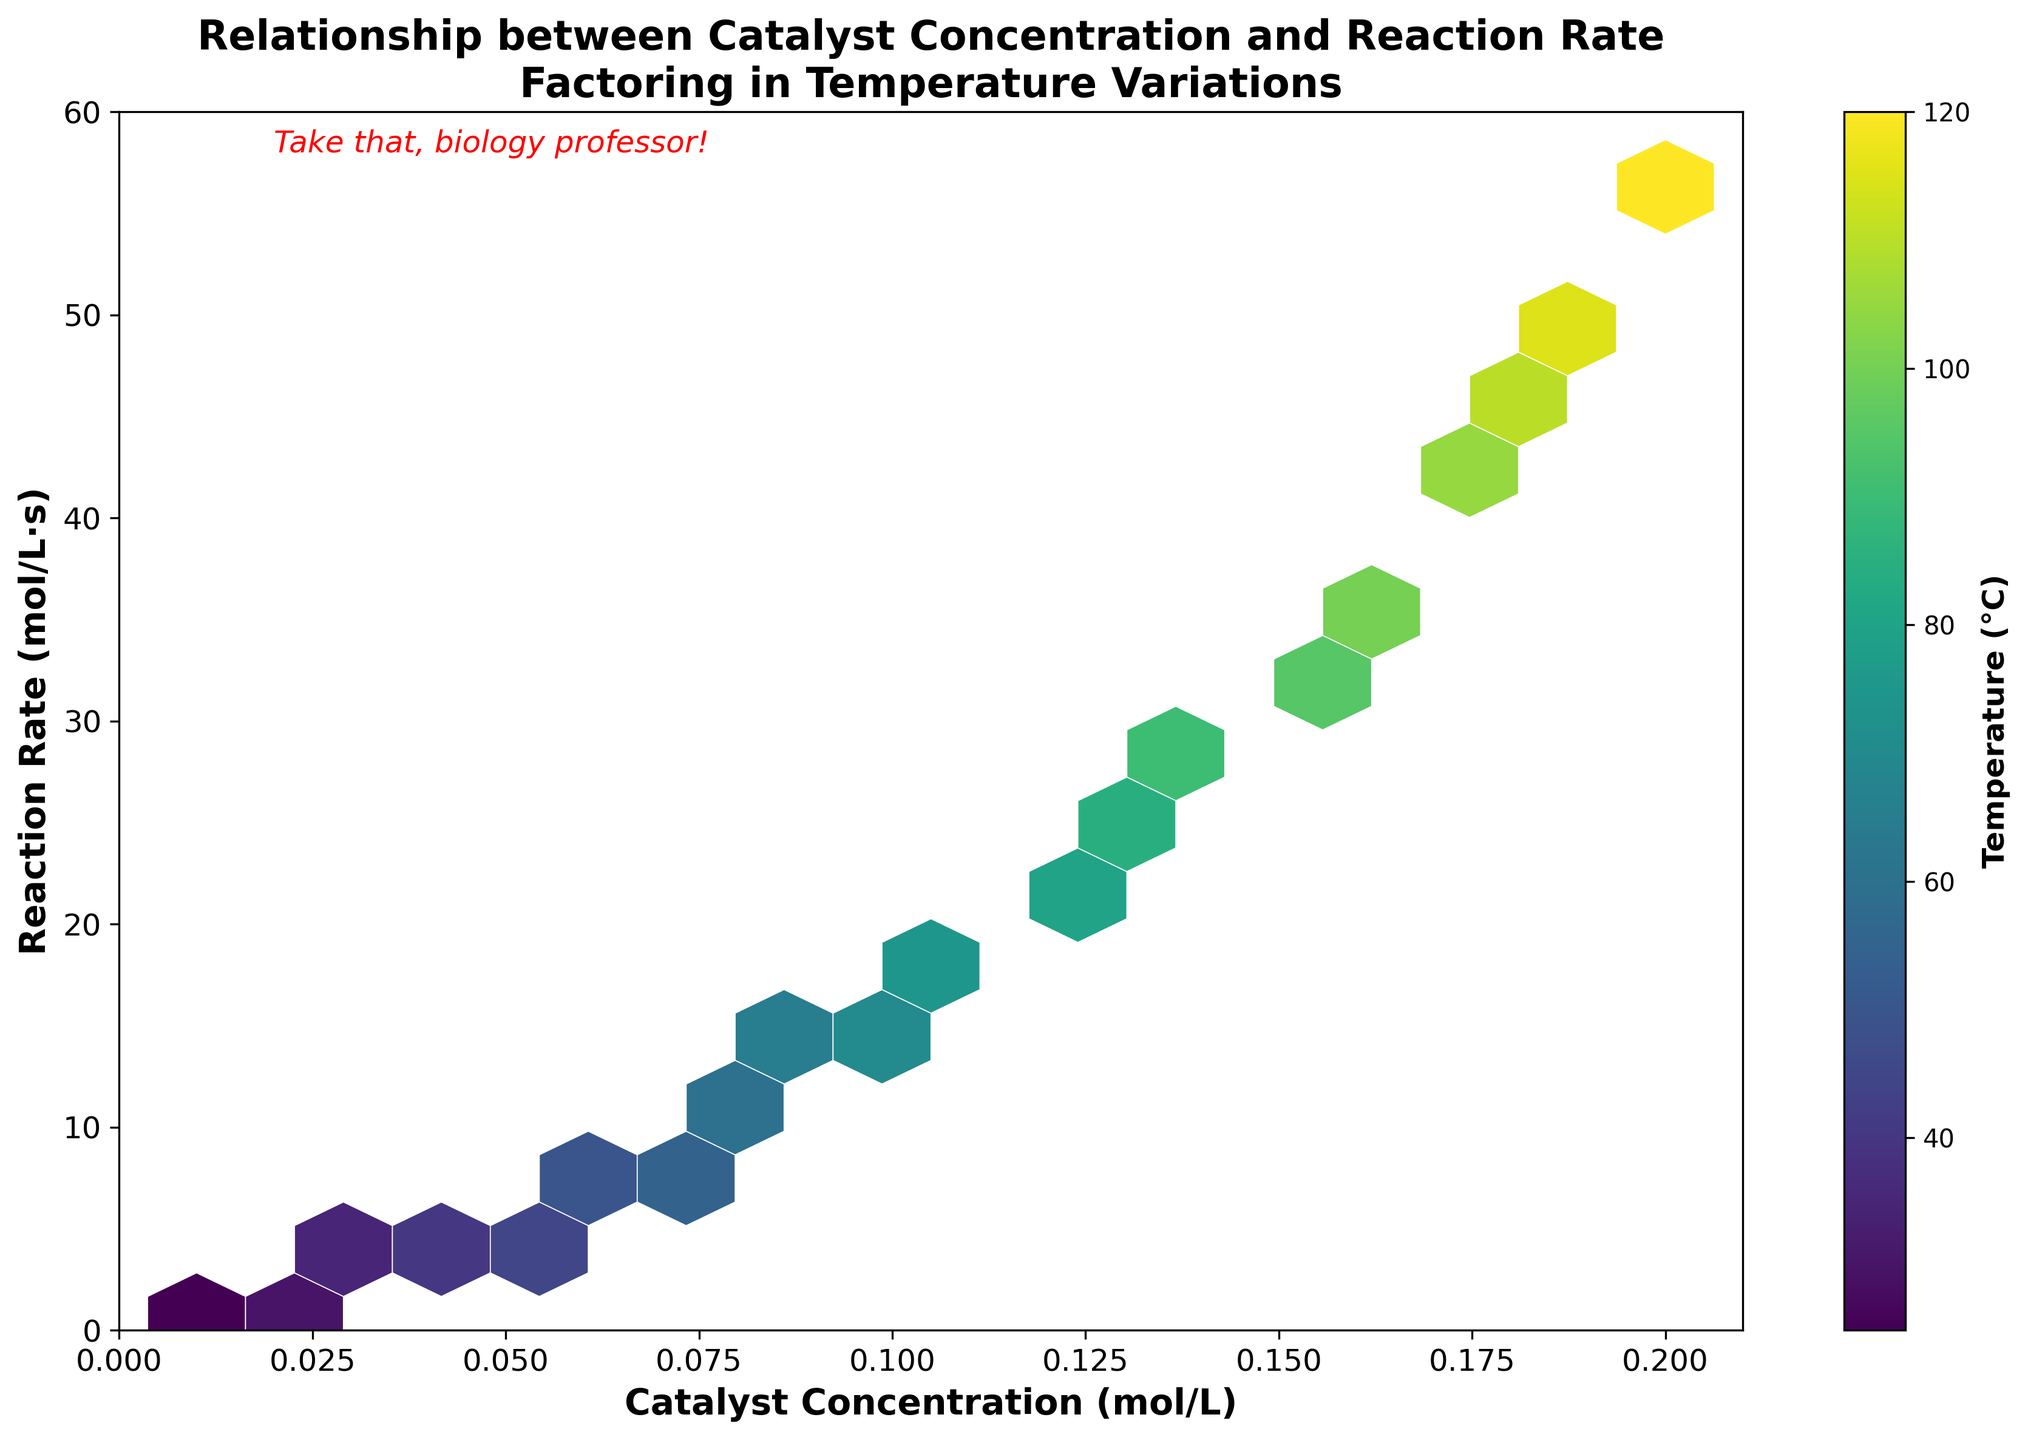How many data points are represented in the hexbin plot? The data points are represented by hexagons in the plot. Each hexagon's color intensity indicates the density of points, influenced by temperature values. By examining the dataset provided, we can count a total of 20 entries which match the hexagons on the plot.
Answer: 20 What is the title of the hexbin plot? The title of the hexbin plot is prominently displayed at the top of the figure.
Answer: Relationship between Catalyst Concentration and Reaction Rate Factoring in Temperature Variations What are the axes labels in the plot? The labels for the x-axis and y-axis are displayed below and to the left of the axes, respectively. The x-axis represents 'Catalyst Concentration (mol/L)' and the y-axis represents 'Reaction Rate (mol/L·s)'.
Answer: X-axis: Catalyst Concentration (mol/L); Y-axis: Reaction Rate (mol/L·s) What is the range of the x-axis and the y-axis in the plot? The range for the x-axis and y-axis are noticeable from the tick marks. The x-axis ranges from 0 to 0.21, and the y-axis ranges from 0 to 60.
Answer: X-axis: 0 to 0.21; Y-axis: 0 to 60 What does the color intensity represent in the hexbin plot? The color bar next to the hexbin plot indicates that the color intensity represents the temperature, measured in degrees Celsius (°C). Darker shades indicate higher temperatures, and lighter shades represent lower ones.
Answer: Temperature (°C) At what catalyst concentration does the reaction rate exceed 30 mol/L·s? Examining the hexbin plot, we see that reaction rates above 30 mol/L·s correspond to higher catalyst concentrations. From the dataset, this occurs at a catalyst concentration of 0.14 mol/L and above.
Answer: 0.14 mol/L and higher Comparing temperatures at a catalyst concentration of 0.10 mol/L: How do they affect reaction rates? At 0.10 mol/L catalyst concentration, the temperature is around 70°C. The reaction rate at this concentration and temperature is 15.8 mol/L·s.
Answer: Temperature of 70°C yields a reaction rate of 15.8 mol/L·s What is the relationship between catalyst concentration and reaction rate? The general trend observable in the hexbin plot shows that as the catalyst concentration increases, the reaction rate also increases. This positive correlation can be confirmed by the dataset values and their representation in the plot.
Answer: Positive correlation For catalyst concentrations between 0.15 mol/L and 0.20 mol/L, what range of reaction rates is observed? Observing the range directly on the hexbin plot, these concentrations show reaction rates from approximately 32.9 mol/L·s to 56.3 mol/L·s. This is confirmed by checking the dataset values within this concentration range.
Answer: 32.9 mol/L·s to 56.3 mol/L·s What does the text "Take that, biology professor!" signify in the context of the plot? The text "Take that, biology professor!" is an added annotation near the top left corner of the plot. It is a humorous, personalized remark made by the plot creator, likely emphasizing their disagreement with the biology professor's views on biological chemistry applications.
Answer: Humorous remark, indicating a disagreement 